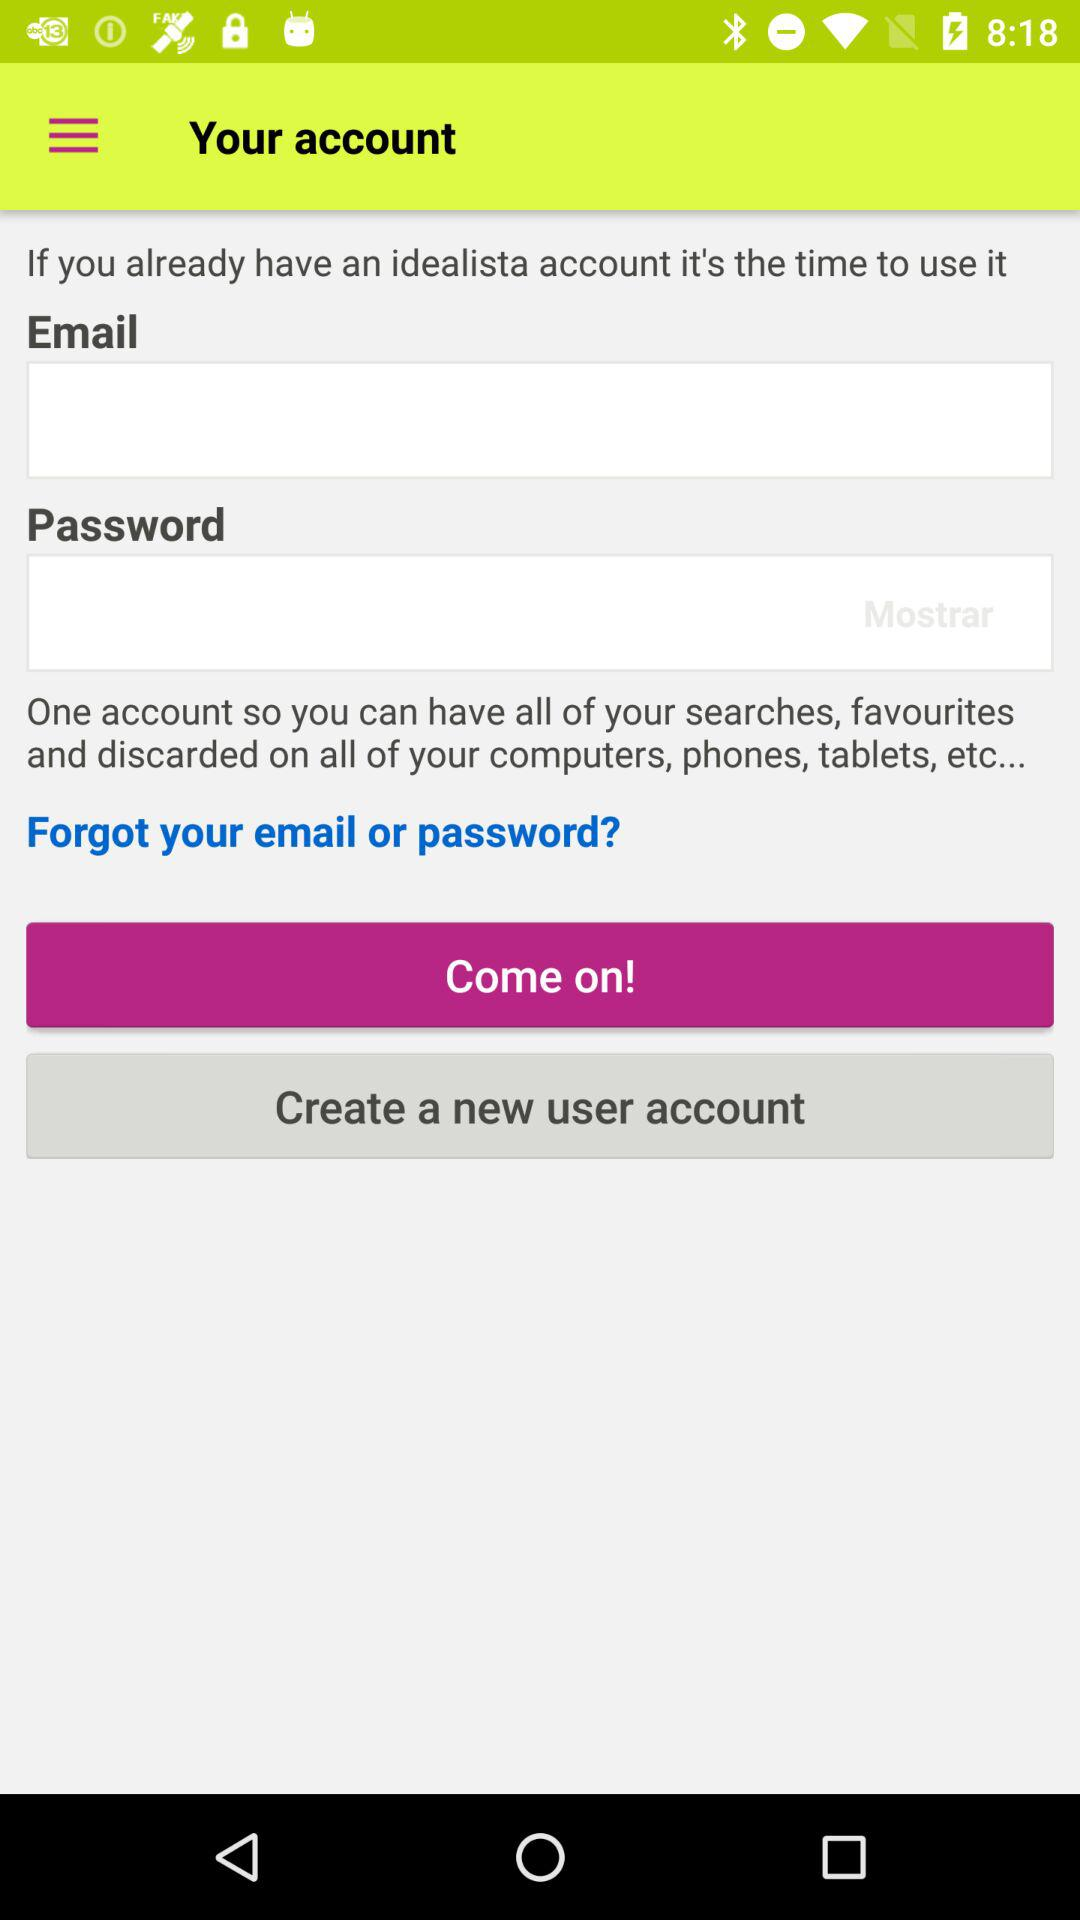How many text inputs are there for the login form?
Answer the question using a single word or phrase. 2 